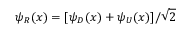<formula> <loc_0><loc_0><loc_500><loc_500>\psi _ { R } ( x ) = [ \psi _ { D } ( x ) + \psi _ { U } ( x ) ] / \sqrt { 2 }</formula> 